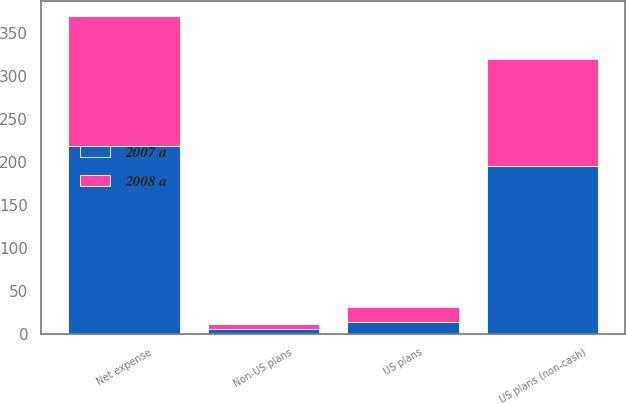<chart> <loc_0><loc_0><loc_500><loc_500><stacked_bar_chart><ecel><fcel>US plans (non-cash)<fcel>Non-US plans<fcel>US plans<fcel>Net expense<nl><fcel>2008 a<fcel>125<fcel>6<fcel>18<fcel>151<nl><fcel>2007 a<fcel>195<fcel>6<fcel>14<fcel>218<nl></chart> 